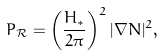<formula> <loc_0><loc_0><loc_500><loc_500>P _ { \mathcal { R } } = \left ( \frac { H _ { * } } { 2 \pi } \right ) ^ { 2 } | \nabla N | ^ { 2 } ,</formula> 